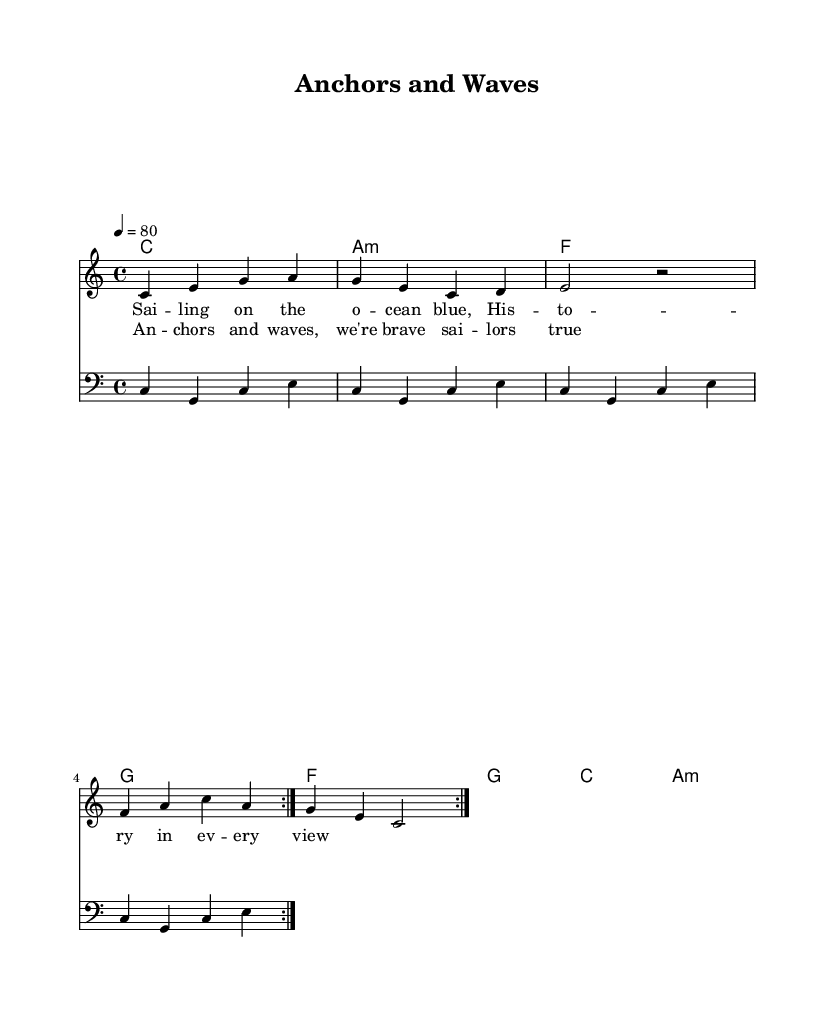what is the key signature of this music? The key signature displayed at the beginning of the music indicates that it is in C major, which has no sharps or flats.
Answer: C major what is the time signature of this music? The time signature is indicated as 4/4, which means there are four beats per measure and the quarter note gets one beat.
Answer: 4/4 what is the tempo of this piece? The tempo marking shows that it is set to 80 beats per minute, indicating the speed at which the piece should be performed.
Answer: 80 how many times is the melody repeated in the composition? The melody part includes a repeat sign (volta), indicating that it should be played twice in total.
Answer: 2 what is the main theme of the lyrics in the song? Analyzing the lyrics, the main theme revolves around maritime elements depicted with phrases reinforcing bravery and connection to the ocean.
Answer: Anchors and waves which chord is played the least number of times in this piece? By comparing the occurrences of each chord in the harmonies, 'f' appears only twice compared to others, implying it is played the least.
Answer: f how does the rhythm of the bassline compare to the melody? The bassline consists of steady quarter notes, providing a rhythmic foundation, while the melody utilizes a mix of quarter and half notes, creating variation.
Answer: Steady vs. varied 